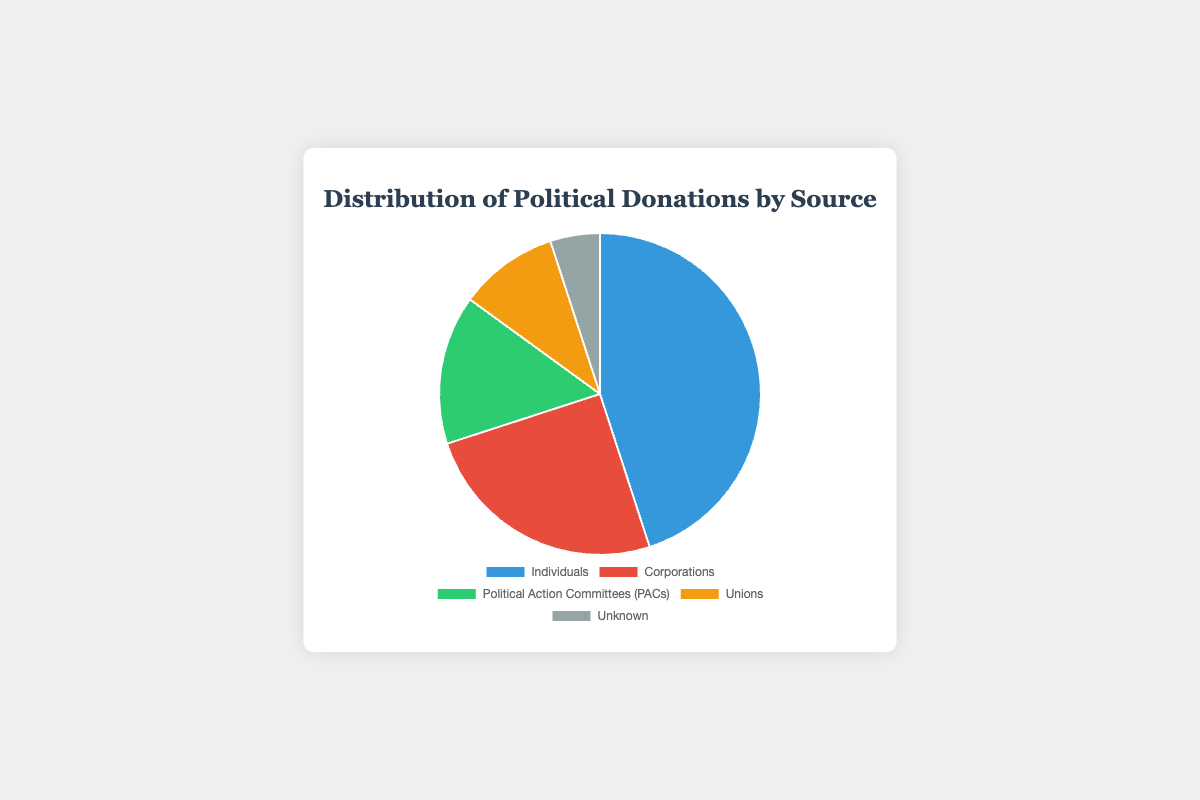what percentage of political donations come from unions and unknown sources combined? Add the percentages of donations from unions (10%) and unknown sources (5%): 10% + 5% = 15%
Answer: 15% Which source contributes the highest percentage of political donations? Individuals contribute the highest percentage at 45%, which is visually the largest segment of the pie chart
Answer: Individuals How much greater is the percentage of donations from corporations compared to donations from unions? Subtract the percentage of donations from unions (10%) from the percentage of donations from corporations (25%): 25% - 10% = 15%
Answer: 15% What is the difference in percentage between donations from Political Action Committees (PACs) and individuals? Subtract the percentage of donations from PACs (15%) from the percentage of donations from individuals (45%): 45% - 15% = 30%
Answer: 30% Which two sources combined equal exactly half (50%) of the total donations? Sum the percentages of donations from corporations (25%) and PACs (15%) equals 40%. Sum of donations from PACs (15%) and unions (10%) equals 25%. Sum of donations from individuals (45%) and unknown sources (5%) equals 50%
Answer: Individuals and Unknown Arrange the sources in descending order of their donation percentages. Individuals (45%), Corporations (25%), PACs (15%), Unions (10%), Unknown (5%)
Answer: Individuals, Corporations, PACs, Unions, Unknown What percentage more do individuals contribute compared to PACs? Subtract the percentage of donations from PACs (15%) from the percentage of donations from individuals (45%): 45% - 15% = 30%
Answer: 30% Which source has the smallest contribution, and what is its percentage? The segment labeled "Unknown" is the smallest, and it represents 5% of the total donations
Answer: Unknown, 5% 